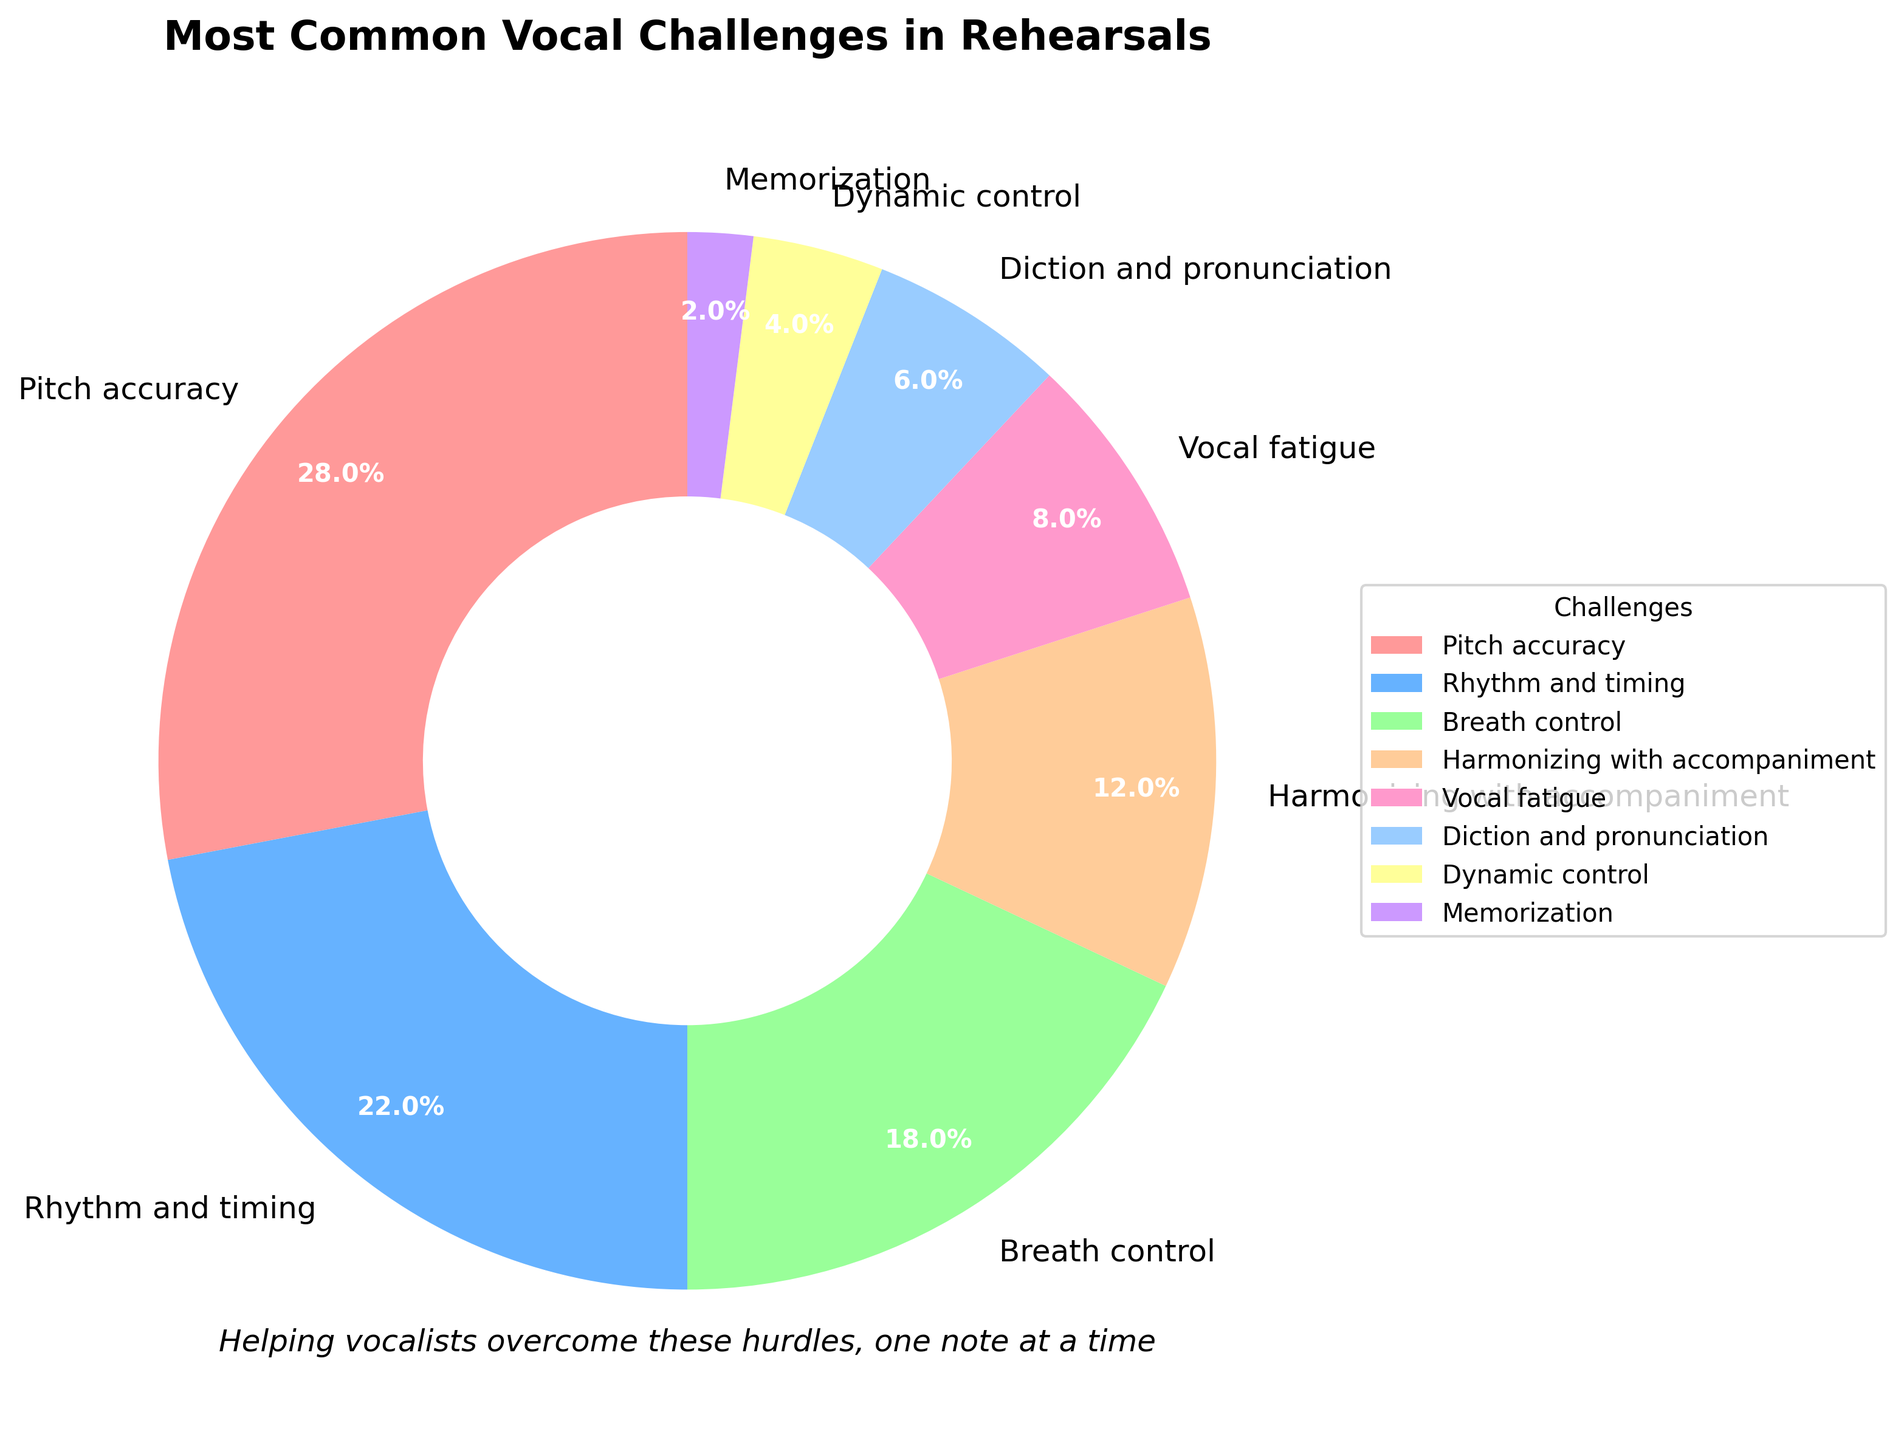What is the most common vocal challenge faced by singers during rehearsals? The figure shows that "Pitch accuracy" has the largest slice of the pie chart, indicating it's the most common challenge.
Answer: Pitch accuracy Which two vocal challenges combined account for exactly half of the issues faced by singers during rehearsals? The percentages for "Pitch accuracy" (28%) and "Rhythm and timing" (22%) add up to 50%.
Answer: Pitch accuracy and Rhythm and timing How does the percentage for Breath control compare to Harmonizing with accompaniment? The slice for "Breath control" is 18%, while "Harmonizing with accompaniment" is 12%, which makes "Breath control" greater by 6%.
Answer: Breath control is greater by 6% What percentage of vocal challenges is attributed to issues other than Pitch accuracy, Rhythm and timing, and Breath control? Adding the specified challenges: 28% (Pitch accuracy) + 22% (Rhythm and timing) + 18% (Breath control) = 68%. Subtracting this from 100%, we get 100% - 68% = 32%.
Answer: 32% Is Vocal fatigue more of a challenge than Diction and pronunciation? The percentage for "Vocal fatigue" is 8%, while "Diction and pronunciation" is 6%, so "Vocal fatigue" is more of a challenge.
Answer: Yes Which challenge has the smallest slice, and what percentage does it represent? The figure shows that "Memorization" has the smallest slice, which represents 2%.
Answer: Memorization, 2% If we group the challenges into those over and under 10%, how many are in each group? The challenges over 10% are: Pitch accuracy (28%), Rhythm and timing (22%), Breath control (18%), and Harmonizing with accompaniment (12%) – 4 in total. The ones under 10% are: Vocal fatigue (8%), Diction and pronunciation (6%), Dynamic control (4%), and Memorization (2%) – 4 in total.
Answer: 4 in each group 